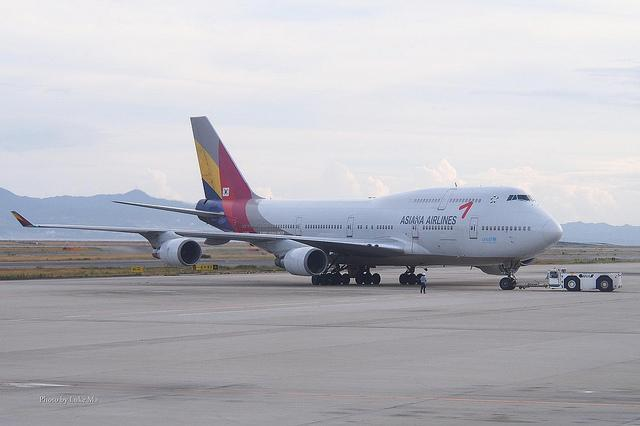This vehicle is most likely from?

Choices:
A) turkey
B) mexico
C) afghanistan
D) south korea south korea 